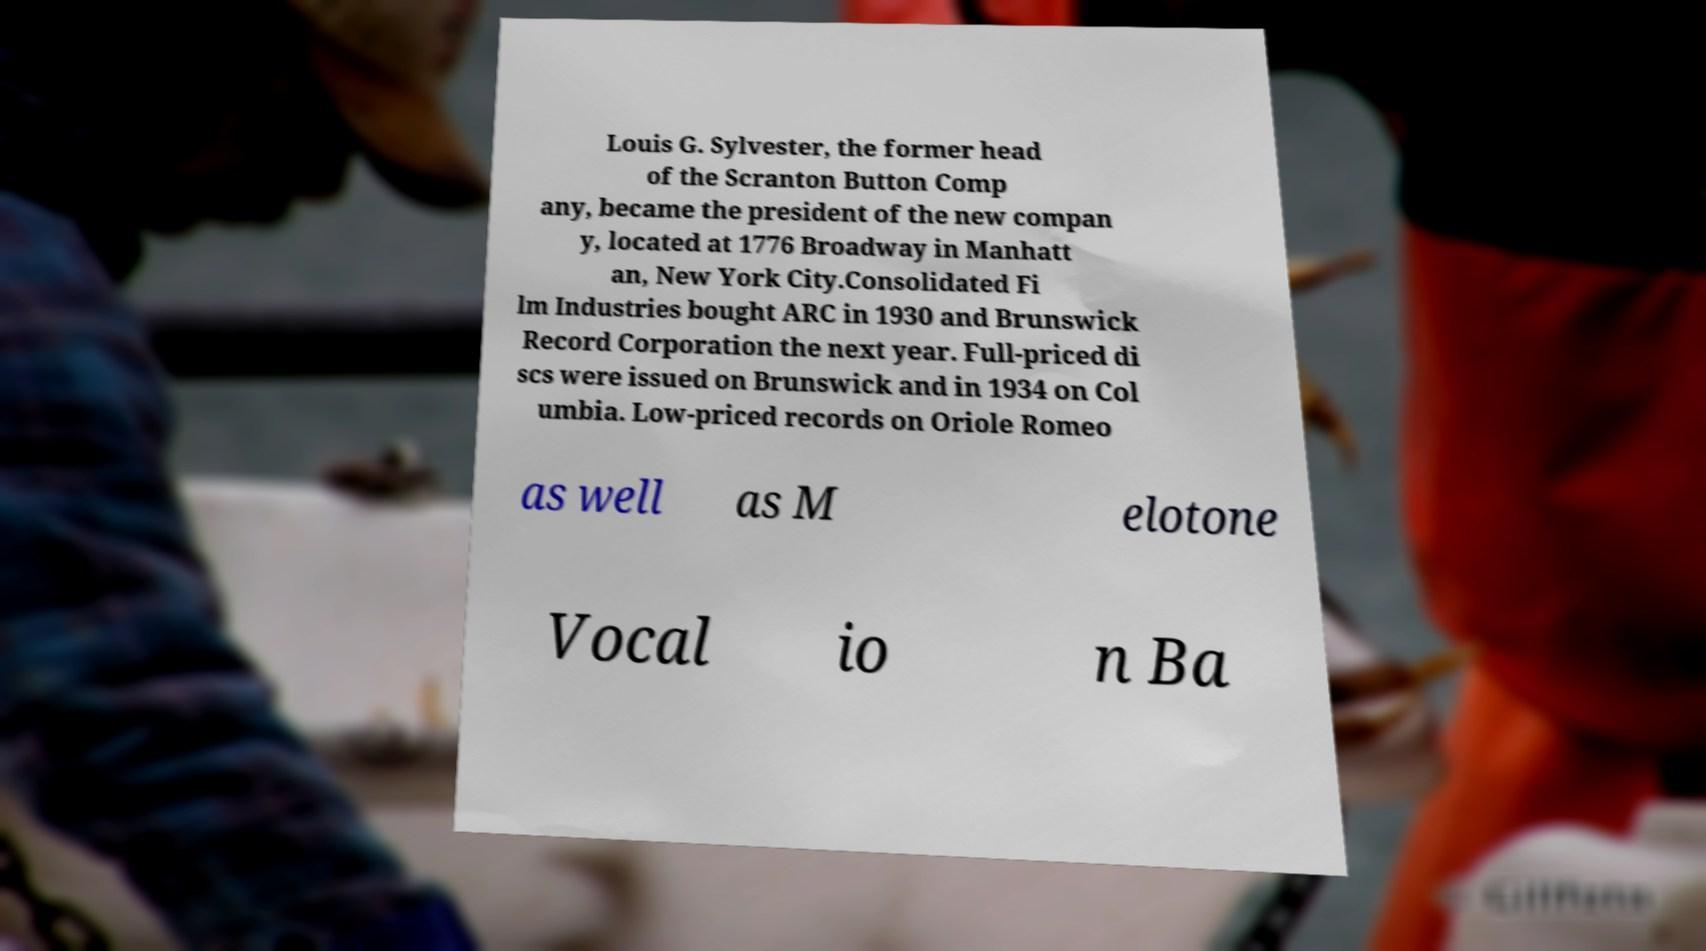There's text embedded in this image that I need extracted. Can you transcribe it verbatim? Louis G. Sylvester, the former head of the Scranton Button Comp any, became the president of the new compan y, located at 1776 Broadway in Manhatt an, New York City.Consolidated Fi lm Industries bought ARC in 1930 and Brunswick Record Corporation the next year. Full-priced di scs were issued on Brunswick and in 1934 on Col umbia. Low-priced records on Oriole Romeo as well as M elotone Vocal io n Ba 